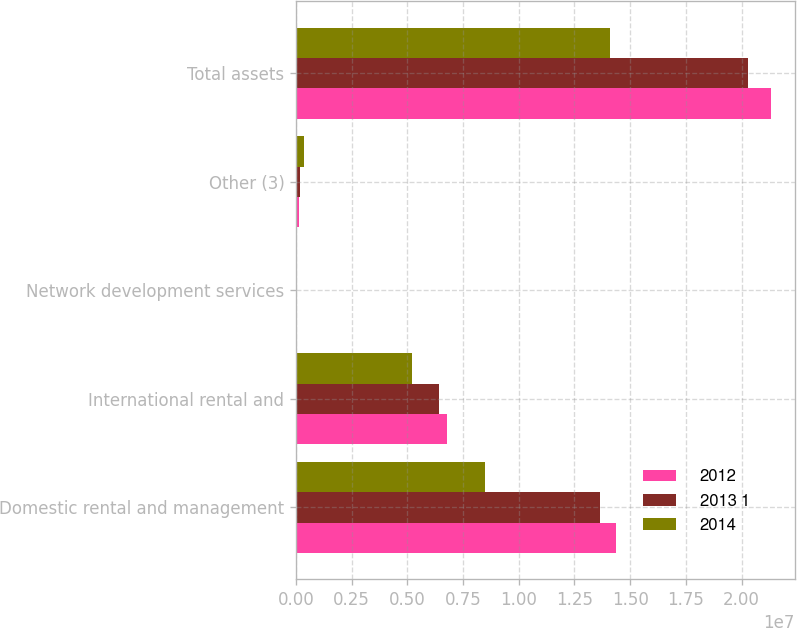<chart> <loc_0><loc_0><loc_500><loc_500><stacked_bar_chart><ecel><fcel>Domestic rental and management<fcel>International rental and<fcel>Network development services<fcel>Other (3)<fcel>Total assets<nl><fcel>2012<fcel>1.43489e+07<fcel>6.77601e+06<fcel>57367<fcel>149273<fcel>2.13315e+07<nl><fcel>2013 1<fcel>1.36281e+07<fcel>6.42844e+06<fcel>47607<fcel>179483<fcel>2.02837e+07<nl><fcel>2014<fcel>8.47117e+06<fcel>5.19099e+06<fcel>63956<fcel>363317<fcel>1.40894e+07<nl></chart> 